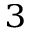Convert formula to latex. <formula><loc_0><loc_0><loc_500><loc_500>^ { 3 }</formula> 